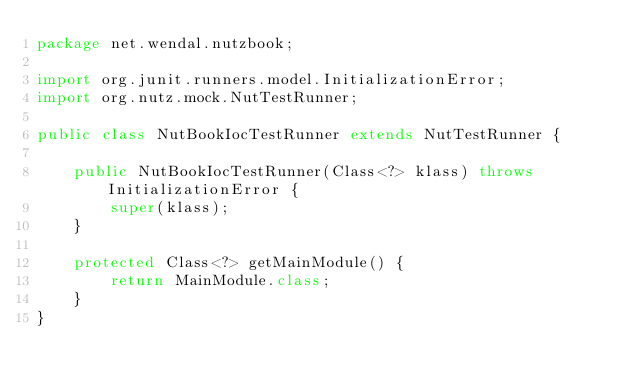<code> <loc_0><loc_0><loc_500><loc_500><_Java_>package net.wendal.nutzbook;

import org.junit.runners.model.InitializationError;
import org.nutz.mock.NutTestRunner;

public class NutBookIocTestRunner extends NutTestRunner {

    public NutBookIocTestRunner(Class<?> klass) throws InitializationError {
        super(klass);
    }

    protected Class<?> getMainModule() {
        return MainModule.class;
    }
}
</code> 